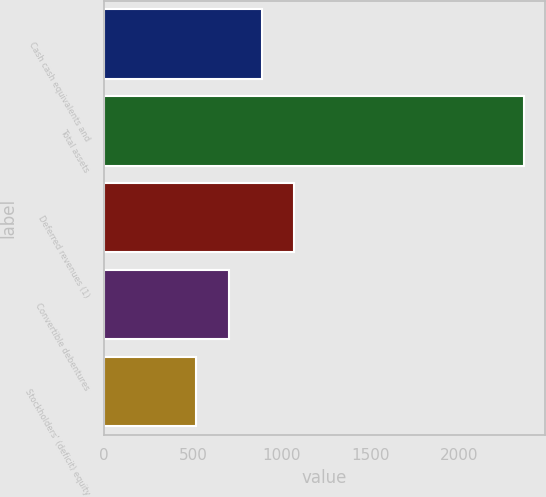Convert chart. <chart><loc_0><loc_0><loc_500><loc_500><bar_chart><fcel>Cash cash equivalents and<fcel>Total assets<fcel>Deferred revenues (1)<fcel>Convertible debentures<fcel>Stockholders' (deficit) equity<nl><fcel>887.8<fcel>2367<fcel>1072.7<fcel>702.9<fcel>518<nl></chart> 